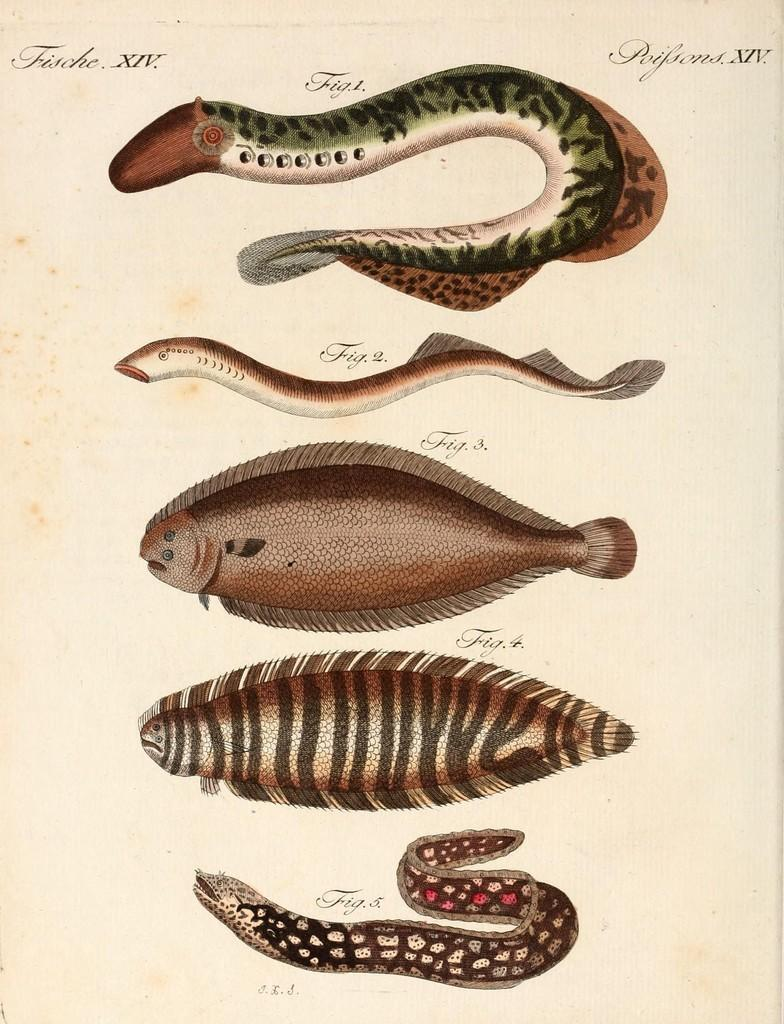What type of animals are depicted in the pictures in the image? There are pictures of reptiles in the image. What medium are the pictures created in? The pictures are painted on paper. Can you see any ants crawling on the pictures of reptiles in the image? There is no mention of ants in the image, so it cannot be determined if any are present. What type of facial expression can be seen on the reptiles in the pictures? The pictures are of reptiles, which are not capable of facial expressions. What type of material is the wool used for in the image? There is no wool present in the image. 